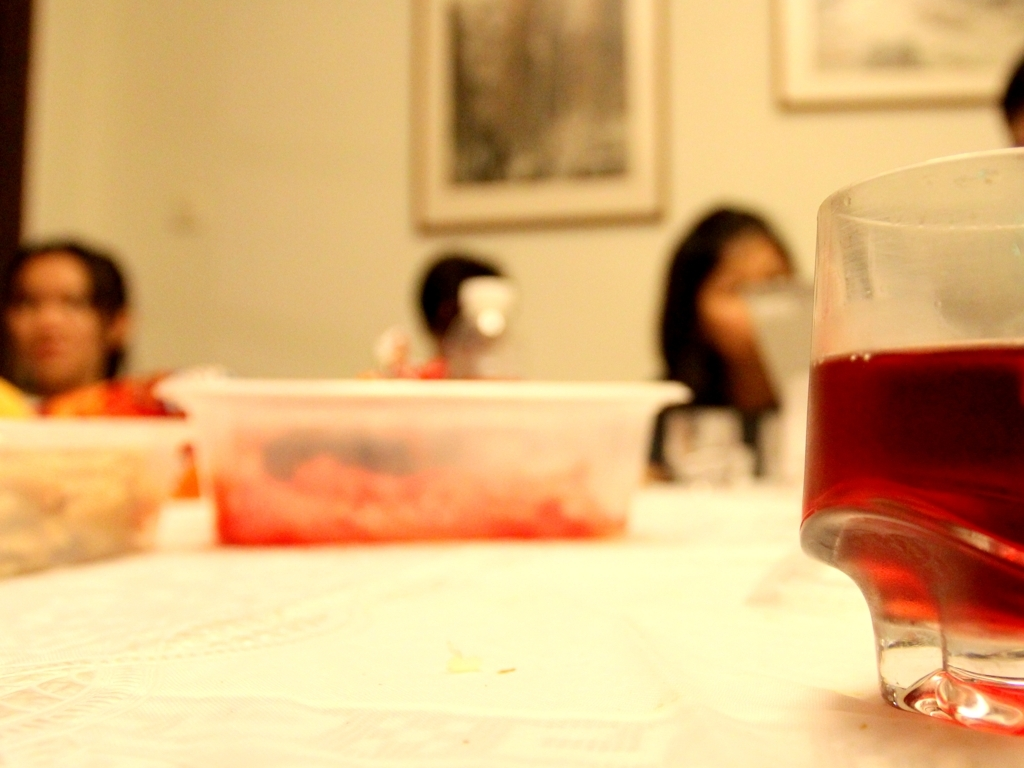Is the image properly focused? The image seems to utilize a shallow depth of field, with the focus on the foreground, particularly around the glass object. The background and the people present are out of focus, which could be a creative choice to draw attention to the foreground. 